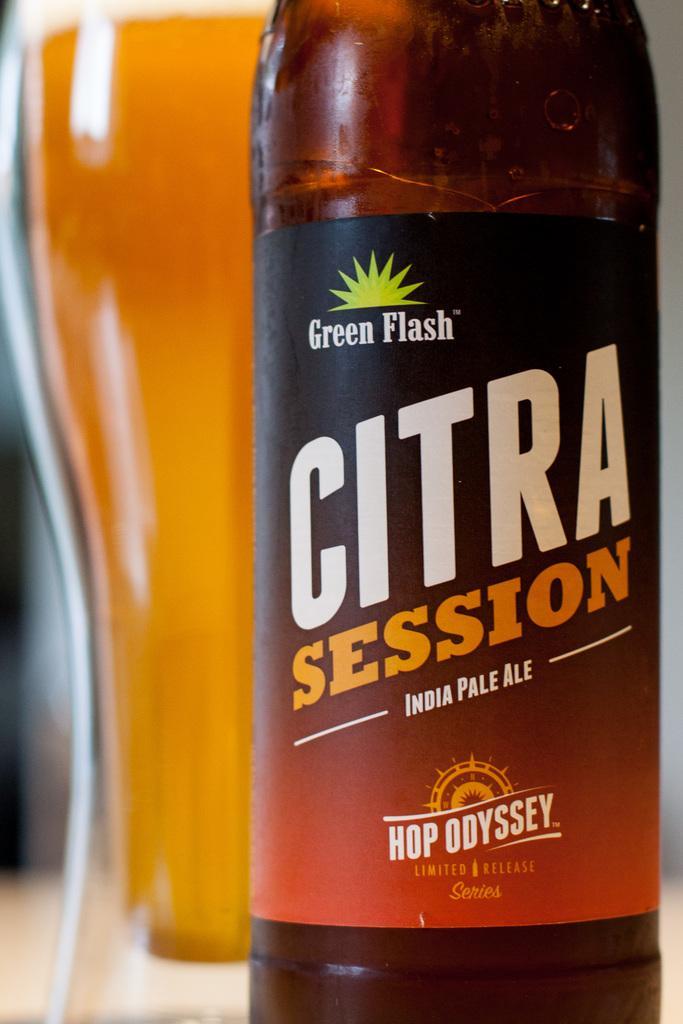In one or two sentences, can you explain what this image depicts? There is a bottle in the foreground area of the image, it seems like a glass behind it. 